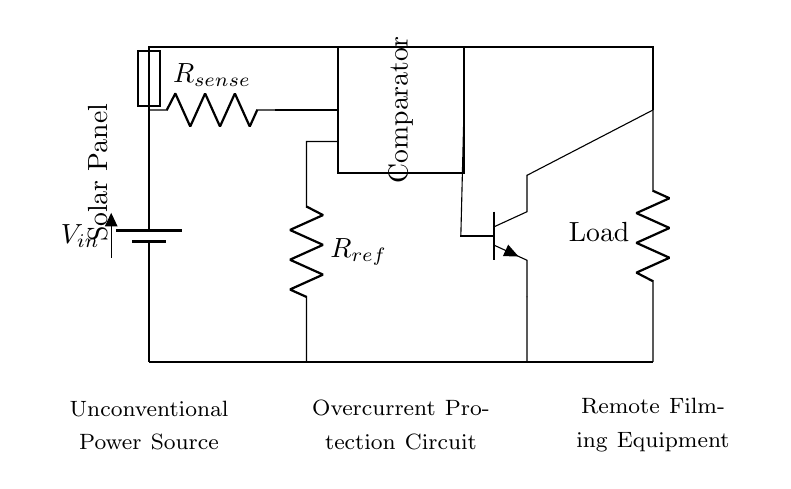What is the type of power source used? The circuit employs a solar panel, indicated at the leftmost side with the label "Solar Panel."
Answer: Solar Panel What is the role of the resistor labeled R sense? R sense is a current sensing resistor, used to measure the current flowing through the circuit and indicate overcurrent conditions.
Answer: Current sensing What connects the output of the comparator to the transistor? The output connection goes from the comparator directly to the base of the transistor. This indicates that the transistor will turn on or off based on the comparator's output.
Answer: Base connection What is the purpose of the fuse in this circuit? The fuse serves as a protective device that will break the circuit in case of an overcurrent condition, preventing damage to the load or other components.
Answer: Protective device What happens when the current exceeds a certain threshold? When the current exceeds the threshold determined by the resistor labeled R ref, the comparator output changes state, triggering the transistor to turn off and disconnect the load.
Answer: Load disconnection How does the reference resistor affect the operation of the circuit? The reference resistor sets the threshold level for the comparator; when the voltage across R sense exceeds this reference, it signals that an overcurrent condition is present.
Answer: Sets threshold 